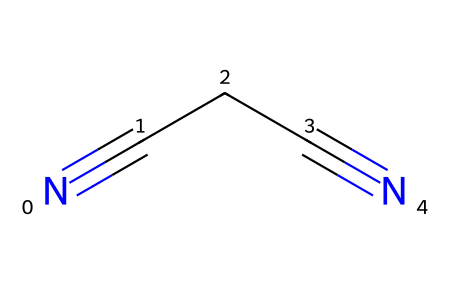How many carbon atoms are present in this chemical? Inspect the structure represented by the SMILES. There are three carbon atoms (C) in the sequence (CCC) of the nitrile, making a total of 3 carbon atoms.
Answer: 3 What is the total number of nitrogen atoms? In the given SMILES, there are two instances of nitrogen atoms (N#), indicating there are a total of 2 nitrogen atoms in the compound.
Answer: 2 What type of functional groups does this compound contain? The structural representation indicates the presence of nitrile functional groups, characterized by the presence of the -C≡N moiety, which consists of a carbon triple-bonded to a nitrogen atom.
Answer: nitrile How many triple bonds are in this compound? Analyzing the structure, there are two triple bonds present: One between the first carbon and nitrogen and the other between the second carbon and nitrogen.
Answer: 2 Is this compound saturated or unsaturated? The presence of triple bonds in the structure indicates that the compound is unsaturated, which goes against the characteristics of saturation where only single bonds would be involved.
Answer: unsaturated What is the IUPAC name of this compound? The structure corresponds to a straight-chain dicarbonitrile with two nitrile groups, thus the IUPAC name is succinonitrile, derived from "succinate" referring to the two-carbon chain and the presence of nitriles.
Answer: succinonitrile 